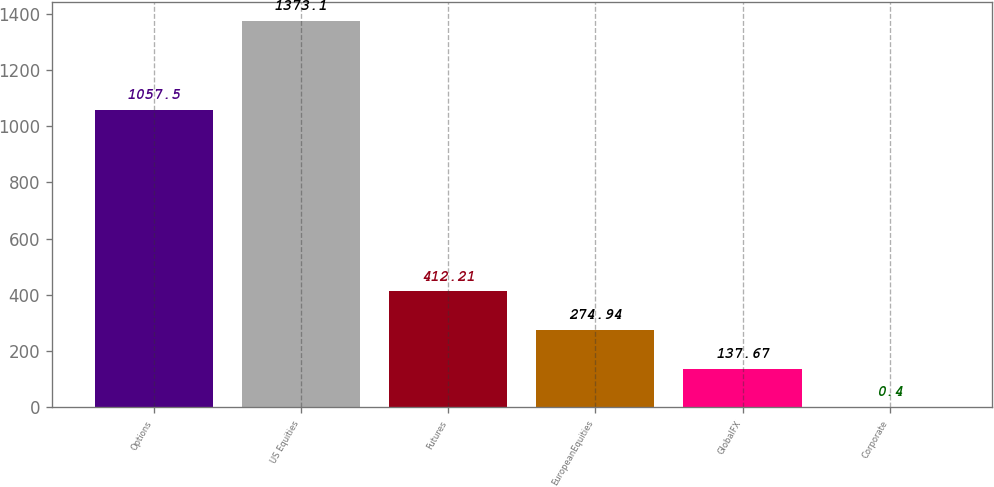<chart> <loc_0><loc_0><loc_500><loc_500><bar_chart><fcel>Options<fcel>US Equities<fcel>Futures<fcel>EuropeanEquities<fcel>GlobalFX<fcel>Corporate<nl><fcel>1057.5<fcel>1373.1<fcel>412.21<fcel>274.94<fcel>137.67<fcel>0.4<nl></chart> 